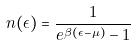<formula> <loc_0><loc_0><loc_500><loc_500>n ( \epsilon ) = \frac { 1 } { e ^ { \beta ( \epsilon - \mu ) } - 1 }</formula> 